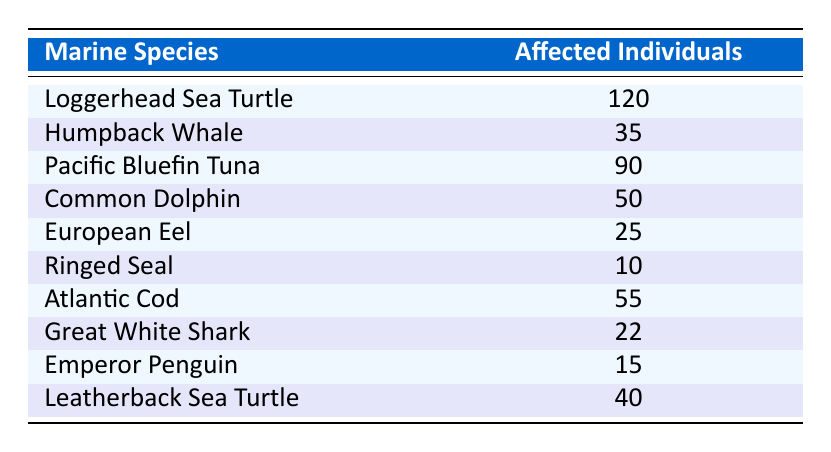What marine species has the highest number of affected individuals? The table indicates that the Loggerhead Sea Turtle has 120 affected individuals, which is the highest compared to the other species listed.
Answer: Loggerhead Sea Turtle How many individuals of the European Eel are affected? The table shows that the European Eel has 25 affected individuals.
Answer: 25 What is the total number of affected individuals among all species listed? To find the total, we add the affected individuals for each species: 120 + 35 + 90 + 50 + 25 + 10 + 55 + 22 + 15 + 40 = 422. Thus, the total number is 422.
Answer: 422 Is the Great White Shark affected by plastic ingestion? Yes, the table lists the Great White Shark with 22 affected individuals.
Answer: Yes Which species has fewer affected individuals: the Ringed Seal or the Leatherback Sea Turtle? The Ringed Seal has 10 affected individuals while the Leatherback Sea Turtle has 40. Since 10 is less than 40, the Ringed Seal has fewer affected individuals.
Answer: Ringed Seal What is the average number of affected individuals across all species listed? First, we calculated the total, which is 422. There are 10 species listed, so the average is 422 divided by 10, which gives us 42.2.
Answer: 42.2 How many species have over 50 individuals affected? By reviewing the table, we see that three species have over 50 affected individuals: Loggerhead Sea Turtle (120), Pacific Bluefin Tuna (90), and Atlantic Cod (55). Therefore, three species exceed this number.
Answer: 3 What is the difference in affected individuals between the Humpback Whale and the Common Dolphin? The Humpback Whale has 35 affected individuals, while the Common Dolphin has 50. The difference is 50 - 35 = 15.
Answer: 15 Are there any species with fewer than 20 affected individuals? Looking at the table, the Ringed Seal (10) and the Emperor Penguin (15) both have fewer than 20 affected individuals. Therefore, there are species that fall below that threshold.
Answer: Yes 